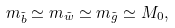Convert formula to latex. <formula><loc_0><loc_0><loc_500><loc_500>m _ { \tilde { b } } \simeq m _ { \tilde { w } } \simeq m _ { \tilde { g } } \simeq M _ { 0 } ,</formula> 